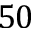<formula> <loc_0><loc_0><loc_500><loc_500>5 0</formula> 